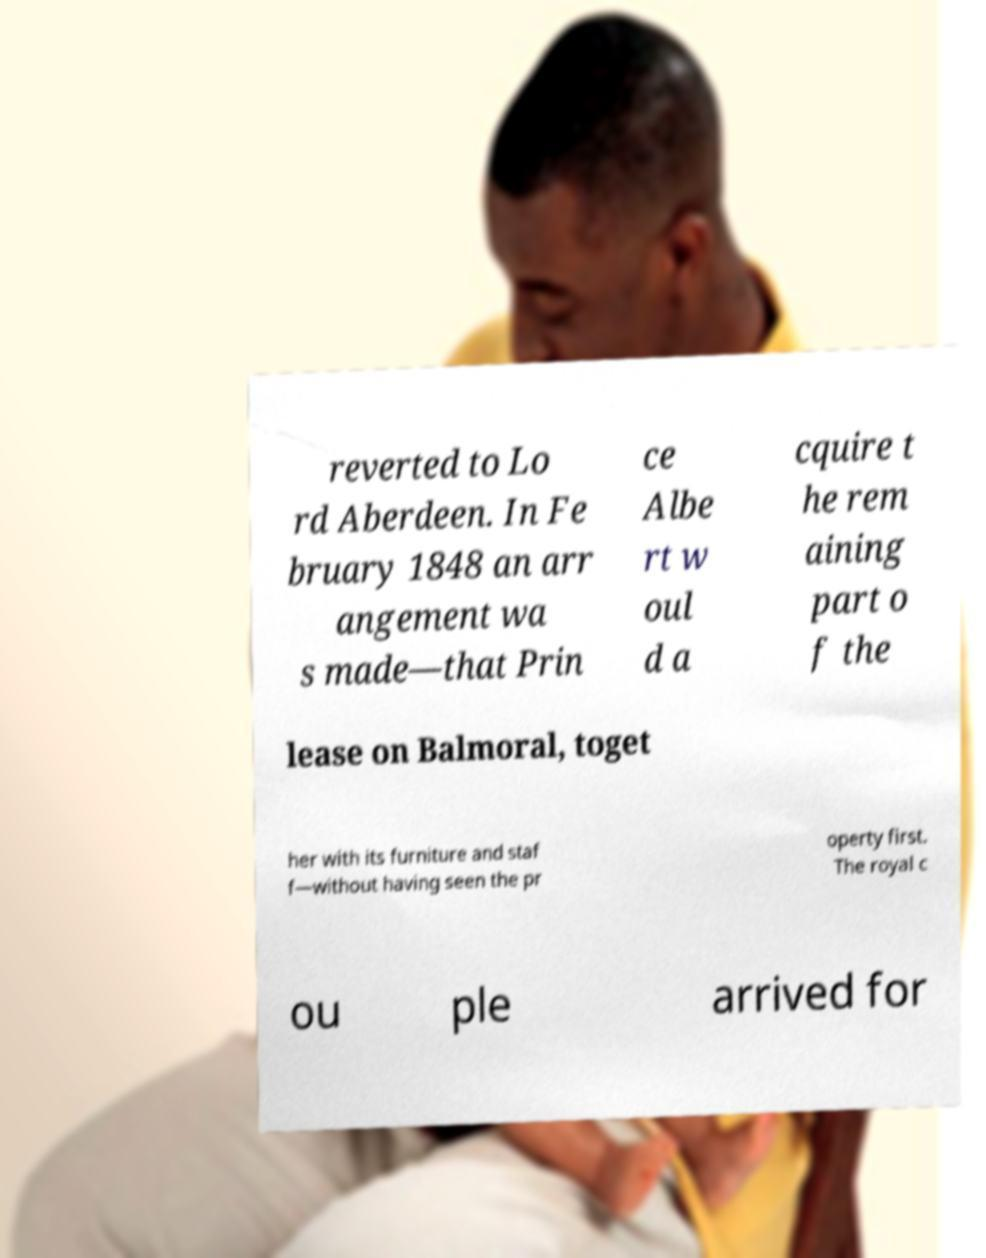Could you assist in decoding the text presented in this image and type it out clearly? reverted to Lo rd Aberdeen. In Fe bruary 1848 an arr angement wa s made—that Prin ce Albe rt w oul d a cquire t he rem aining part o f the lease on Balmoral, toget her with its furniture and staf f—without having seen the pr operty first. The royal c ou ple arrived for 